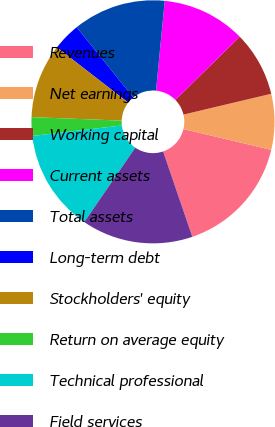Convert chart. <chart><loc_0><loc_0><loc_500><loc_500><pie_chart><fcel>Revenues<fcel>Net earnings<fcel>Working capital<fcel>Current assets<fcel>Total assets<fcel>Long-term debt<fcel>Stockholders' equity<fcel>Return on average equity<fcel>Technical professional<fcel>Field services<nl><fcel>16.05%<fcel>7.41%<fcel>8.64%<fcel>11.11%<fcel>12.35%<fcel>3.7%<fcel>9.88%<fcel>2.47%<fcel>13.58%<fcel>14.81%<nl></chart> 